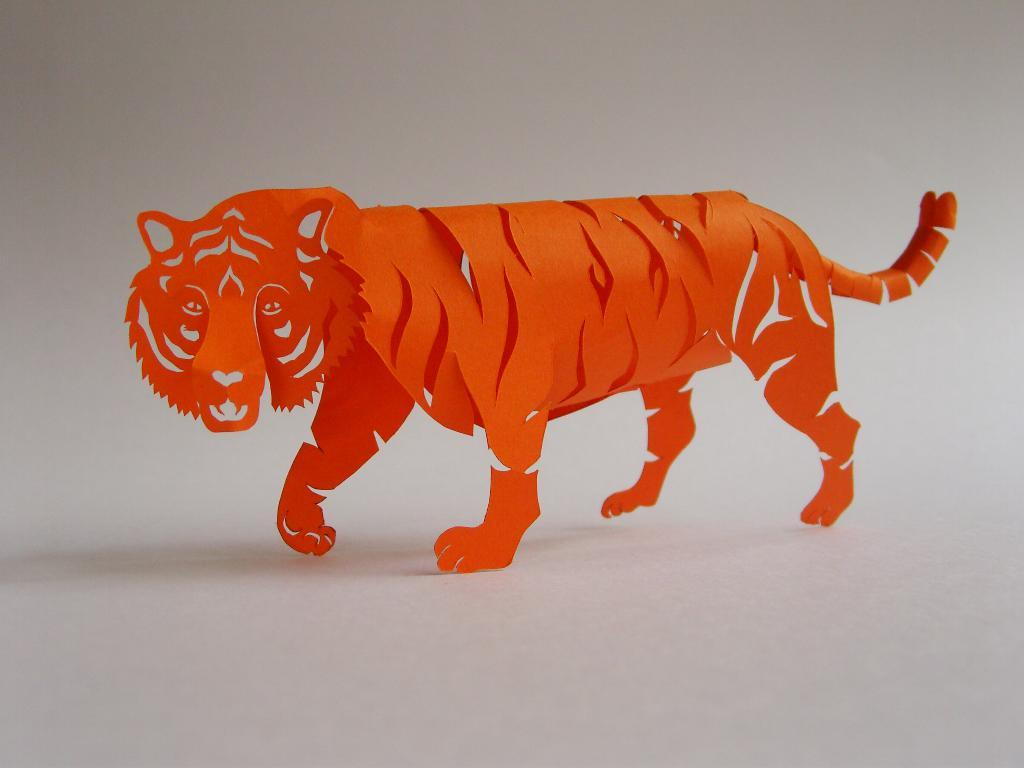What type of animal is depicted in the illustration in the image? The image contains an illustration of a tiger. What color is the tiger in the illustration? The tiger is in orange color. What color is the background of the image? The background of the image is white in color. Is the tiger wearing a collar in the image? There is no collar visible on the tiger in the image. Can you tell me the name of the tiger's son in the image? There is no information about a son or any other family members of the tiger in the image. 